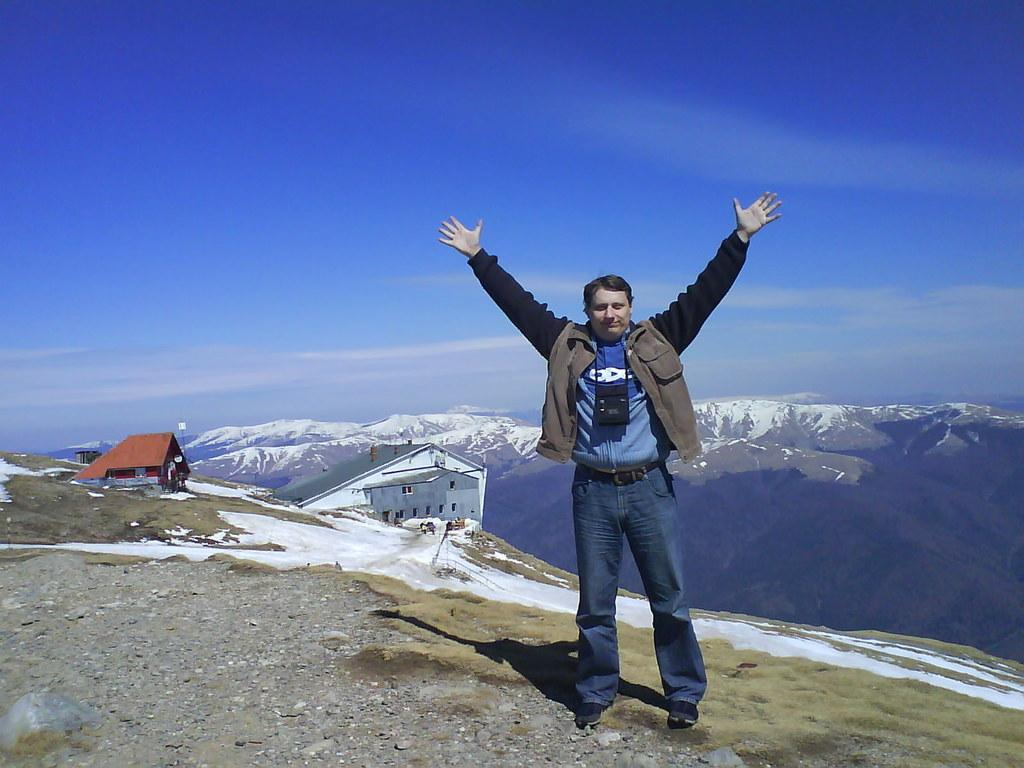What is the main subject of the image? There is a person standing in the image. What is the person doing with their hands? The person has their hands open. Where is the image set? The image is set at a hill station. What type of structures can be seen in the image? There are buildings visible in the image. What is visible at the top of the image? The sky is visible at the top of the image. What type of chalk is being used by the person in the image? There is no chalk present in the image; the person has their hands open but not holding any chalk. Can you describe the waves in the image? There are no waves present in the image; it is set at a hill station with no visible water bodies. 